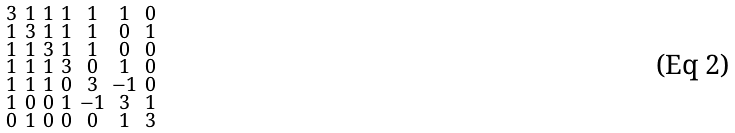Convert formula to latex. <formula><loc_0><loc_0><loc_500><loc_500>\begin{smallmatrix} 3 & 1 & 1 & 1 & 1 & 1 & 0 \\ 1 & 3 & 1 & 1 & 1 & 0 & 1 \\ 1 & 1 & 3 & 1 & 1 & 0 & 0 \\ 1 & 1 & 1 & 3 & 0 & 1 & 0 \\ 1 & 1 & 1 & 0 & 3 & - 1 & 0 \\ 1 & 0 & 0 & 1 & - 1 & 3 & 1 \\ 0 & 1 & 0 & 0 & 0 & 1 & 3 \end{smallmatrix}</formula> 